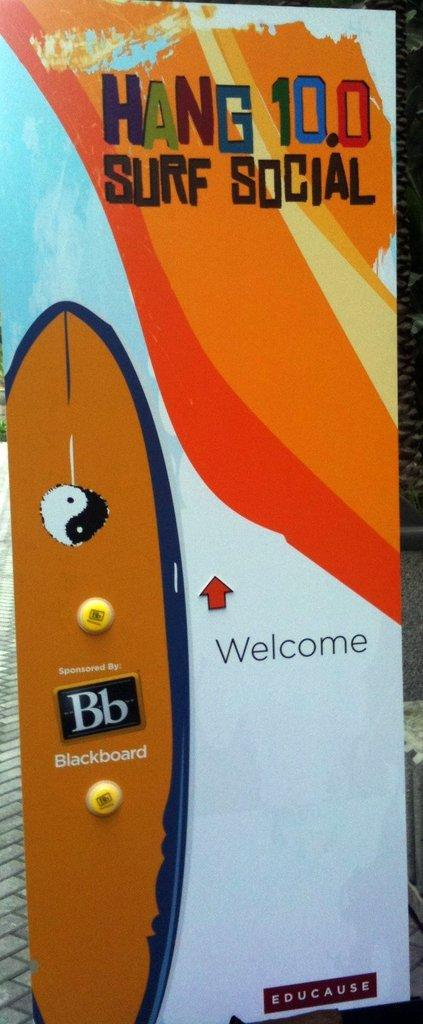What is present on the path in the image? There is a banner on the path in the image. What can be found on the banner? There is text on the banner. What is located on the right side of the image? There is a tree trunk on the right side of the image. How many goldfish can be seen swimming in the image? There are no goldfish present in the image. What type of tool is being used to cut the banner in the image? There is no tool or cutting activity depicted in the image. 